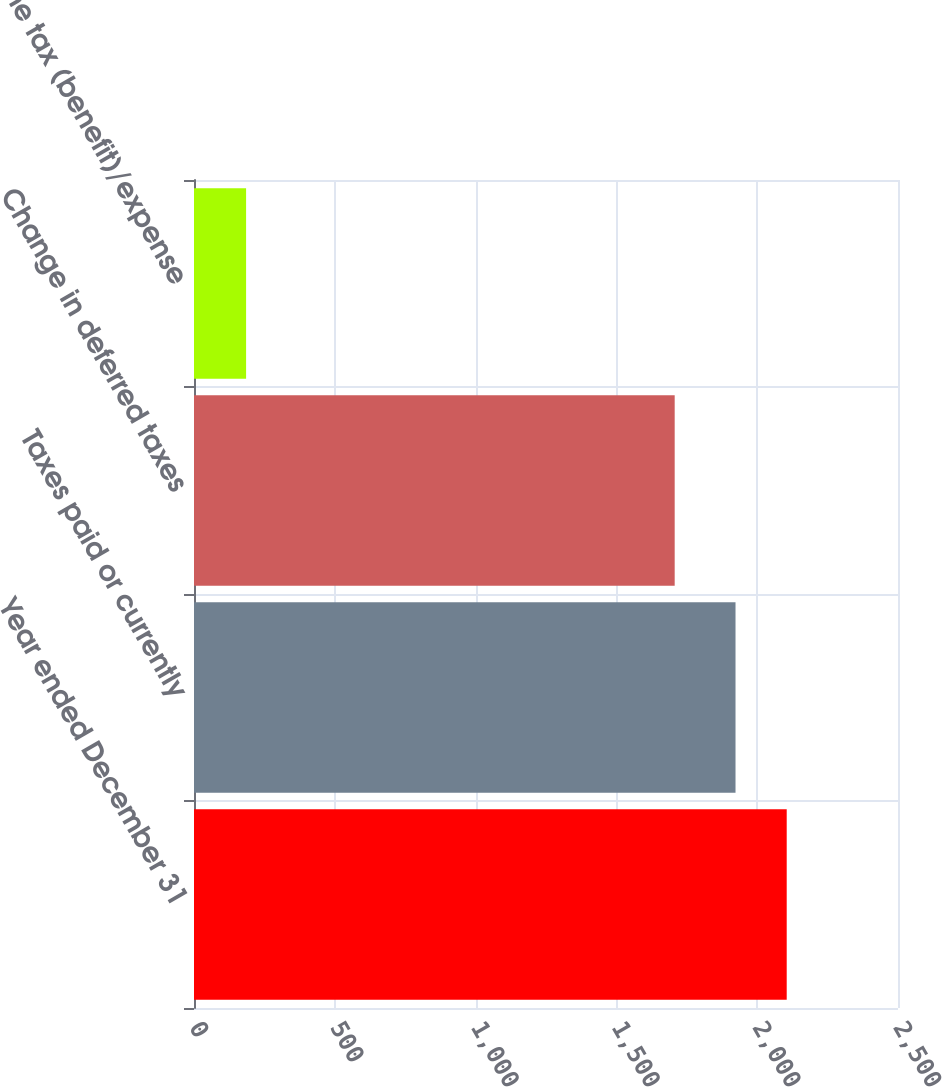<chart> <loc_0><loc_0><loc_500><loc_500><bar_chart><fcel>Year ended December 31<fcel>Taxes paid or currently<fcel>Change in deferred taxes<fcel>Income tax (benefit)/expense<nl><fcel>2104.8<fcel>1923<fcel>1707<fcel>185<nl></chart> 